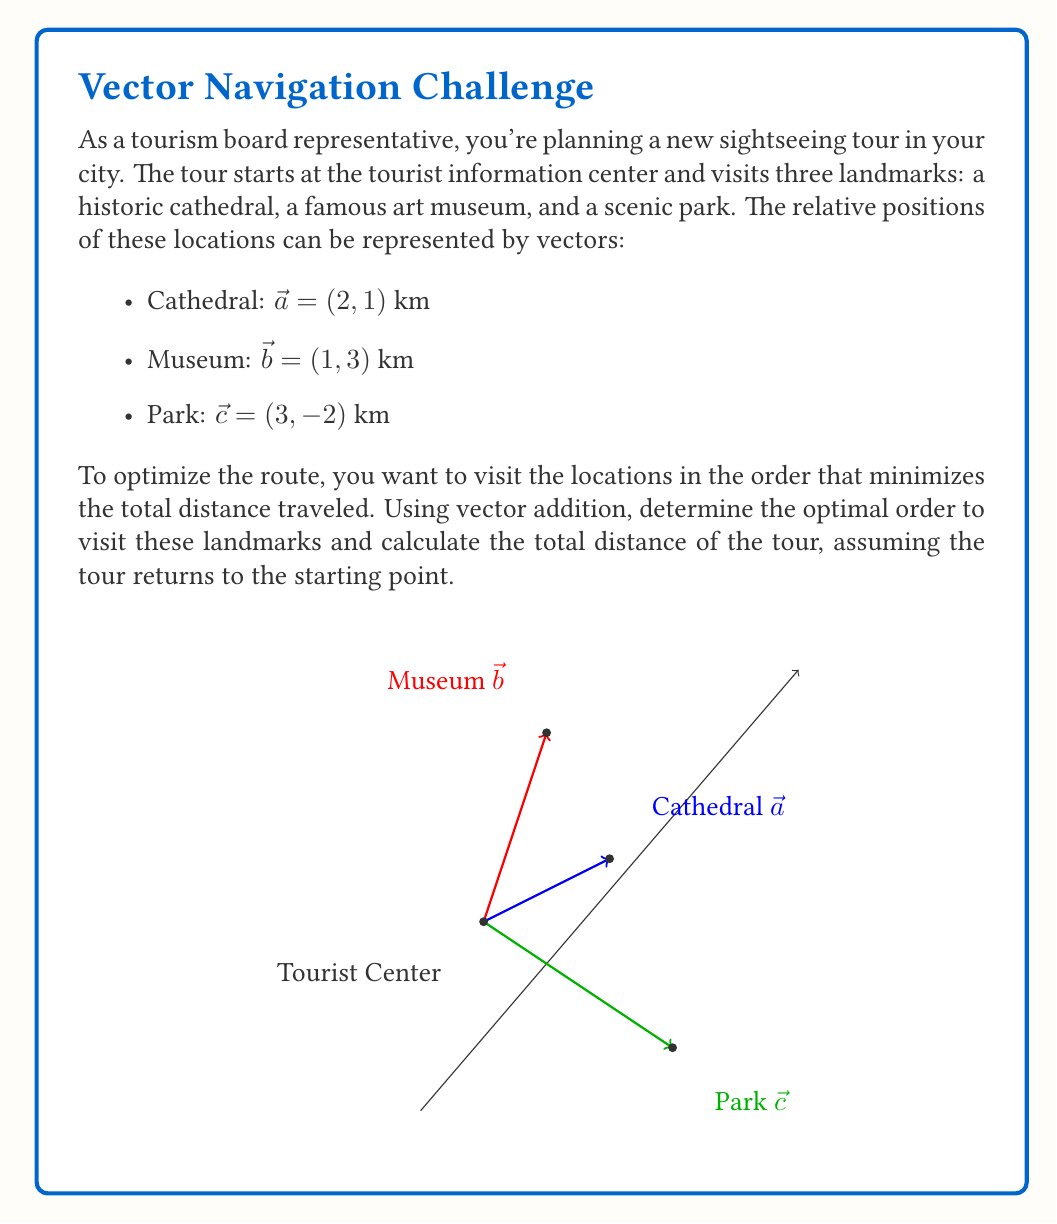Show me your answer to this math problem. Let's approach this step-by-step:

1) First, we need to calculate the distances between each pair of locations, including the tourist center (origin). We can do this using the magnitude of the difference between vectors:

   Tourist Center to Cathedral: $|\vec{a}| = \sqrt{2^2 + 1^2} = \sqrt{5}$ km
   Tourist Center to Museum: $|\vec{b}| = \sqrt{1^2 + 3^2} = \sqrt{10}$ km
   Tourist Center to Park: $|\vec{c}| = \sqrt{3^2 + (-2)^2} = \sqrt{13}$ km
   Cathedral to Museum: $|\vec{b} - \vec{a}| = |(1-2, 3-1)| = |(-1, 2)| = \sqrt{5}$ km
   Cathedral to Park: $|\vec{c} - \vec{a}| = |(3-2, -2-1)| = |(1, -3)| = \sqrt{10}$ km
   Museum to Park: $|\vec{c} - \vec{b}| = |(3-1, -2-3)| = |(2, -5)| = \sqrt{29}$ km

2) Now, we need to consider all possible routes and calculate their total distances:

   Route 1: Center → Cathedral → Museum → Park → Center
   Distance = $\sqrt{5} + \sqrt{5} + \sqrt{29} + \sqrt{13} ≈ 11.38$ km

   Route 2: Center → Cathedral → Park → Museum → Center
   Distance = $\sqrt{5} + \sqrt{10} + \sqrt{29} + \sqrt{10} ≈ 13.20$ km

   Route 3: Center → Museum → Cathedral → Park → Center
   Distance = $\sqrt{10} + \sqrt{5} + \sqrt{10} + \sqrt{13} ≈ 11.38$ km

   Route 4: Center → Museum → Park → Cathedral → Center
   Distance = $\sqrt{10} + \sqrt{29} + \sqrt{10} + \sqrt{5} ≈ 13.20$ km

   Route 5: Center → Park → Cathedral → Museum → Center
   Distance = $\sqrt{13} + \sqrt{10} + \sqrt{5} + \sqrt{10} ≈ 11.38$ km

   Route 6: Center → Park → Museum → Cathedral → Center
   Distance = $\sqrt{13} + \sqrt{29} + \sqrt{5} + \sqrt{5} ≈ 13.20$ km

3) The optimal route is the one with the shortest total distance. From our calculations, we can see that Routes 1, 3, and 5 all have the same minimum distance of approximately 11.38 km.

4) For the sake of providing a specific answer, let's choose Route 1: Tourist Center → Cathedral → Museum → Park → Tourist Center.

5) We can represent this route using vector addition:
   $\vec{a} + (\vec{b} - \vec{a}) + (\vec{c} - \vec{b}) + (-\vec{c})$

   This simplifies to $\vec{a} + \vec{b} - \vec{a} + \vec{c} - \vec{b} - \vec{c} = \vec{0}$, which confirms that we return to the starting point.
Answer: Optimal route: Tourist Center → Cathedral → Museum → Park → Tourist Center. Total distance: $\sqrt{5} + \sqrt{5} + \sqrt{29} + \sqrt{13} ≈ 11.38$ km 